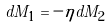<formula> <loc_0><loc_0><loc_500><loc_500>d M _ { 1 } = - \eta d M _ { 2 }</formula> 